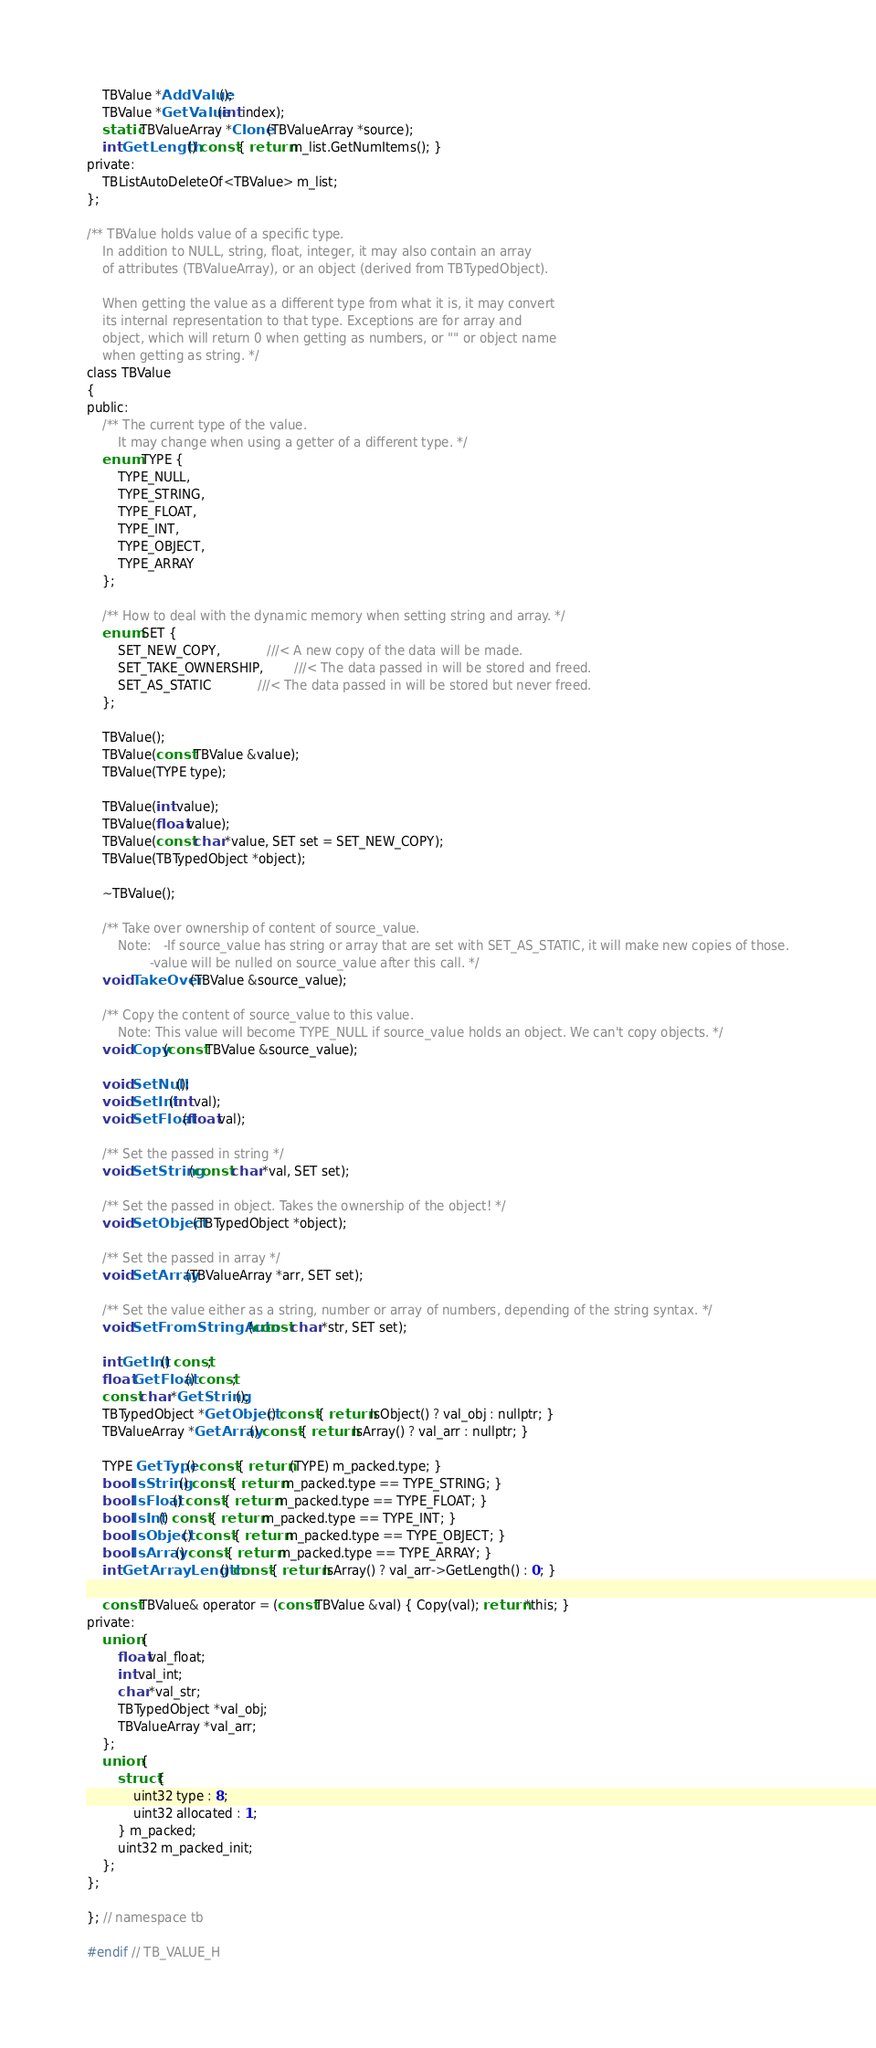Convert code to text. <code><loc_0><loc_0><loc_500><loc_500><_C_>    TBValue *AddValue();
    TBValue *GetValue(int index);
    static TBValueArray *Clone(TBValueArray *source);
    int GetLength() const { return m_list.GetNumItems(); }
private:
    TBListAutoDeleteOf<TBValue> m_list;
};

/** TBValue holds value of a specific type.
    In addition to NULL, string, float, integer, it may also contain an array
    of attributes (TBValueArray), or an object (derived from TBTypedObject).

    When getting the value as a different type from what it is, it may convert
    its internal representation to that type. Exceptions are for array and
    object, which will return 0 when getting as numbers, or "" or object name
    when getting as string. */
class TBValue
{
public:
    /** The current type of the value.
        It may change when using a getter of a different type. */
    enum TYPE {
        TYPE_NULL,
        TYPE_STRING,
        TYPE_FLOAT,
        TYPE_INT,
        TYPE_OBJECT,
        TYPE_ARRAY
    };

    /** How to deal with the dynamic memory when setting string and array. */
    enum SET {
        SET_NEW_COPY,			///< A new copy of the data will be made.
        SET_TAKE_OWNERSHIP,		///< The data passed in will be stored and freed.
        SET_AS_STATIC			///< The data passed in will be stored but never freed.
    };

    TBValue();
    TBValue(const TBValue &value);
    TBValue(TYPE type);

    TBValue(int value);
    TBValue(float value);
    TBValue(const char *value, SET set = SET_NEW_COPY);
    TBValue(TBTypedObject *object);

    ~TBValue();

    /** Take over ownership of content of source_value.
        Note:	-If source_value has string or array that are set with SET_AS_STATIC, it will make new copies of those.
                -value will be nulled on source_value after this call. */
    void TakeOver(TBValue &source_value);

    /** Copy the content of source_value to this value.
        Note: This value will become TYPE_NULL if source_value holds an object. We can't copy objects. */
    void Copy(const TBValue &source_value);

    void SetNull();
    void SetInt(int val);
    void SetFloat(float val);

    /** Set the passed in string */
    void SetString(const char *val, SET set);

    /** Set the passed in object. Takes the ownership of the object! */
    void SetObject(TBTypedObject *object);

    /** Set the passed in array */
    void SetArray(TBValueArray *arr, SET set);

    /** Set the value either as a string, number or array of numbers, depending of the string syntax. */
    void SetFromStringAuto(const char *str, SET set);

    int GetInt() const;
    float GetFloat() const;
    const char *GetString();
    TBTypedObject *GetObject() const { return IsObject() ? val_obj : nullptr; }
    TBValueArray *GetArray() const { return IsArray() ? val_arr : nullptr; }

    TYPE GetType() const { return (TYPE) m_packed.type; }
    bool IsString() const { return m_packed.type == TYPE_STRING; }
    bool IsFloat() const { return m_packed.type == TYPE_FLOAT; }
    bool IsInt() const { return m_packed.type == TYPE_INT; }
    bool IsObject() const { return m_packed.type == TYPE_OBJECT; }
    bool IsArray() const { return m_packed.type == TYPE_ARRAY; }
    int GetArrayLength() const { return IsArray() ? val_arr->GetLength() : 0; }

    const TBValue& operator = (const TBValue &val) { Copy(val); return *this; }
private:
    union {
        float val_float;
        int val_int;
        char *val_str;
        TBTypedObject *val_obj;
        TBValueArray *val_arr;
    };
    union {
        struct {
            uint32 type : 8;
            uint32 allocated : 1;
        } m_packed;
        uint32 m_packed_init;
    };
};

}; // namespace tb

#endif // TB_VALUE_H
</code> 